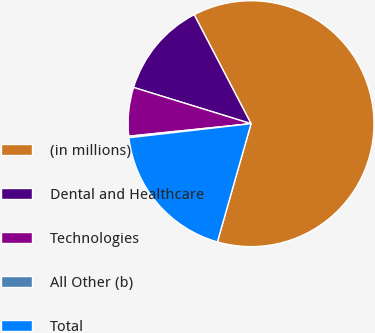Convert chart. <chart><loc_0><loc_0><loc_500><loc_500><pie_chart><fcel>(in millions)<fcel>Dental and Healthcare<fcel>Technologies<fcel>All Other (b)<fcel>Total<nl><fcel>62.07%<fcel>12.58%<fcel>6.39%<fcel>0.2%<fcel>18.76%<nl></chart> 